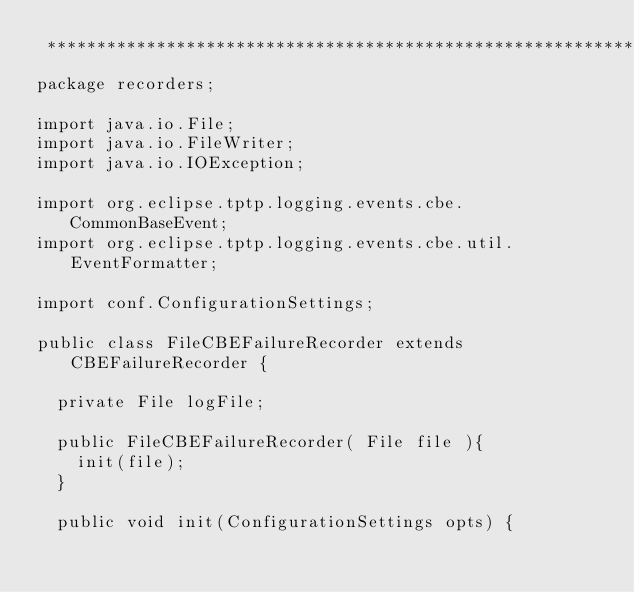Convert code to text. <code><loc_0><loc_0><loc_500><loc_500><_Java_> *******************************************************************************/
package recorders;

import java.io.File;
import java.io.FileWriter;
import java.io.IOException;

import org.eclipse.tptp.logging.events.cbe.CommonBaseEvent;
import org.eclipse.tptp.logging.events.cbe.util.EventFormatter;

import conf.ConfigurationSettings;

public class FileCBEFailureRecorder extends CBEFailureRecorder {

	private File logFile;

	public FileCBEFailureRecorder( File file ){
		init(file);
	}
	
	public void init(ConfigurationSettings opts) {</code> 